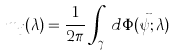Convert formula to latex. <formula><loc_0><loc_0><loc_500><loc_500>m _ { j } ( \lambda ) = \frac { 1 } { 2 \pi } \int _ { \gamma _ { j } } d \Phi ( \vec { \psi } ; \lambda )</formula> 